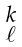<formula> <loc_0><loc_0><loc_500><loc_500>\begin{smallmatrix} k \\ \ell \end{smallmatrix}</formula> 